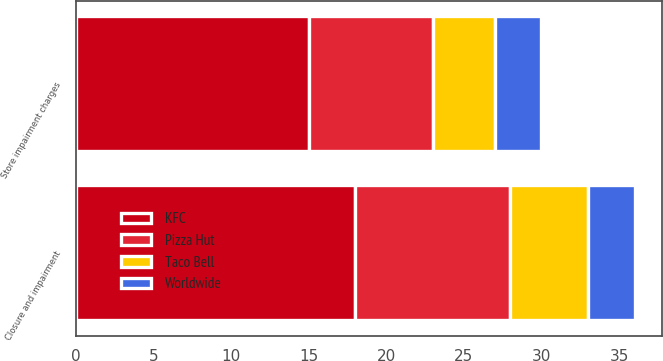Convert chart. <chart><loc_0><loc_0><loc_500><loc_500><stacked_bar_chart><ecel><fcel>Store impairment charges<fcel>Closure and impairment<nl><fcel>Pizza Hut<fcel>8<fcel>10<nl><fcel>Taco Bell<fcel>4<fcel>5<nl><fcel>Worldwide<fcel>3<fcel>3<nl><fcel>KFC<fcel>15<fcel>18<nl></chart> 